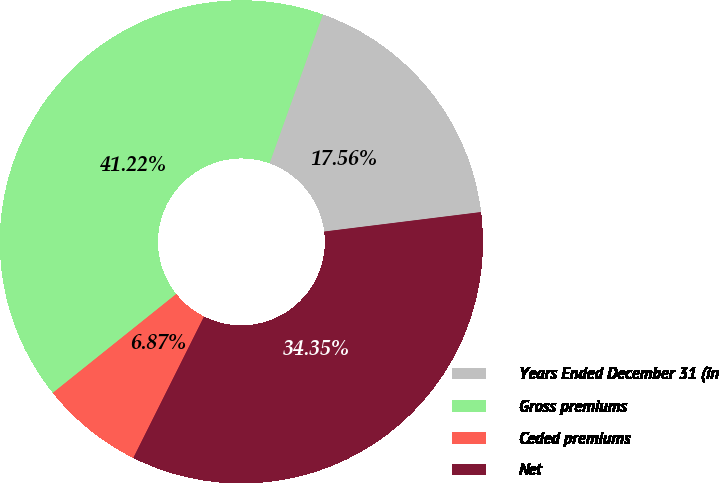<chart> <loc_0><loc_0><loc_500><loc_500><pie_chart><fcel>Years Ended December 31 (in<fcel>Gross premiums<fcel>Ceded premiums<fcel>Net<nl><fcel>17.56%<fcel>41.22%<fcel>6.87%<fcel>34.35%<nl></chart> 